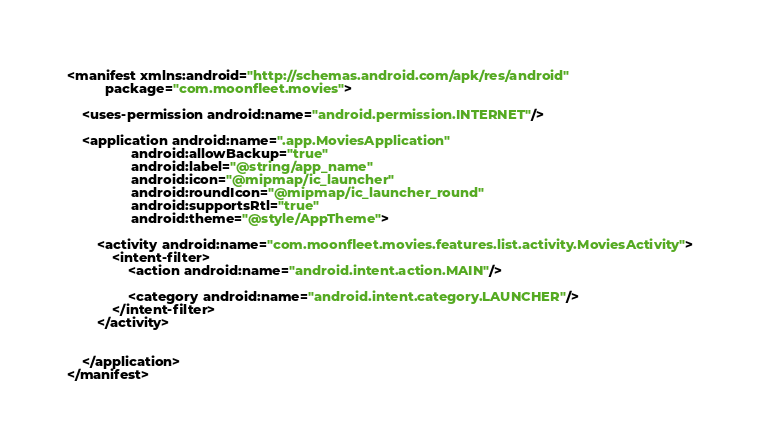Convert code to text. <code><loc_0><loc_0><loc_500><loc_500><_XML_><manifest xmlns:android="http://schemas.android.com/apk/res/android"
          package="com.moonfleet.movies">

    <uses-permission android:name="android.permission.INTERNET"/>

    <application android:name=".app.MoviesApplication"
                 android:allowBackup="true"
                 android:label="@string/app_name"
                 android:icon="@mipmap/ic_launcher"
                 android:roundIcon="@mipmap/ic_launcher_round"
                 android:supportsRtl="true"
                 android:theme="@style/AppTheme">

        <activity android:name="com.moonfleet.movies.features.list.activity.MoviesActivity">
            <intent-filter>
                <action android:name="android.intent.action.MAIN"/>

                <category android:name="android.intent.category.LAUNCHER"/>
            </intent-filter>
        </activity>


    </application>
</manifest>
</code> 